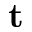<formula> <loc_0><loc_0><loc_500><loc_500>t</formula> 